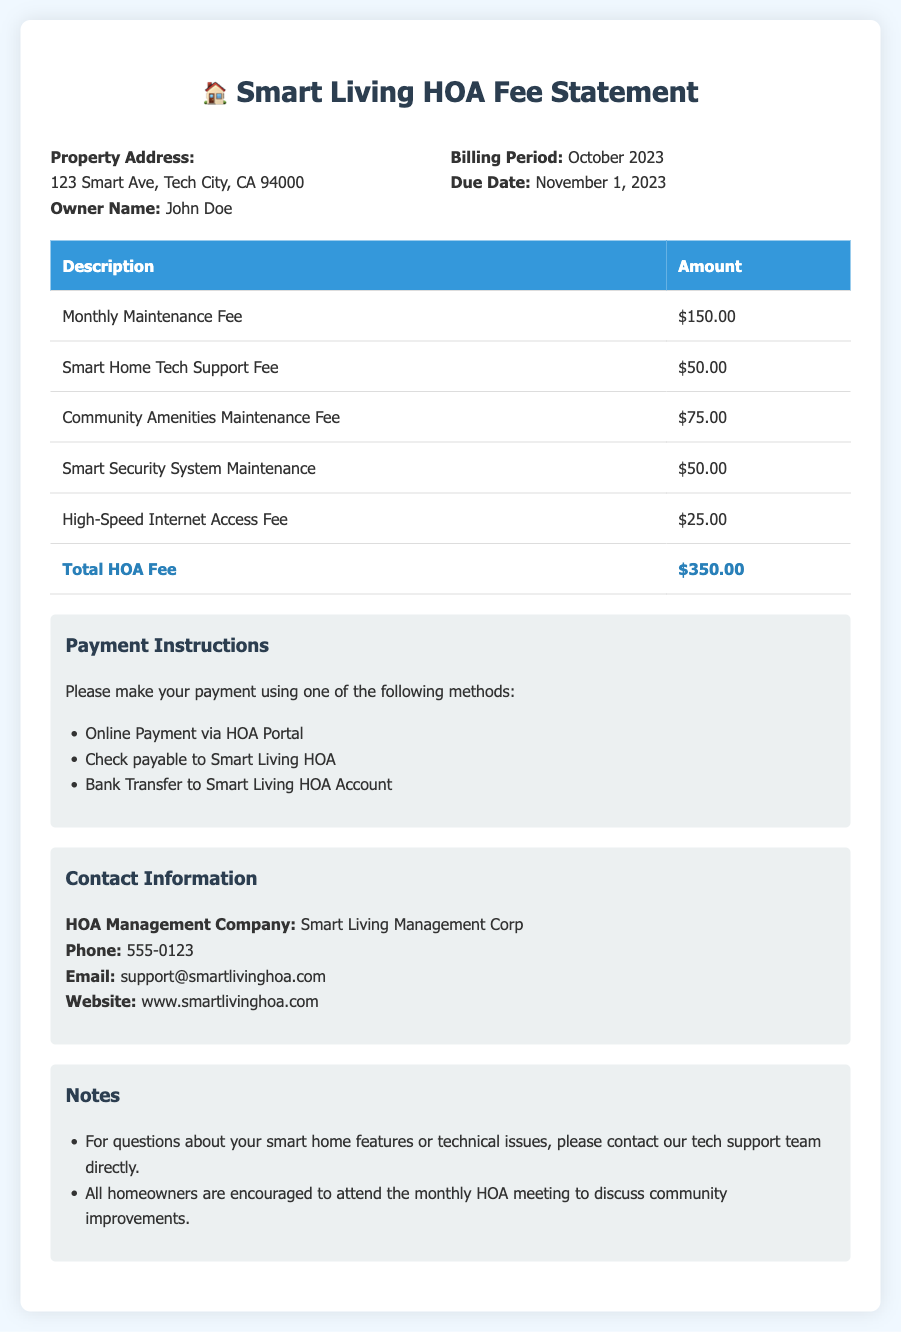What is the property address? The property address is found in the property info section of the document.
Answer: 123 Smart Ave, Tech City, CA 94000 What is the name of the owner? The owner's name is listed in the property info section of the document.
Answer: John Doe What is the billing period? The billing period is stated in the billing info section of the document.
Answer: October 2023 What is the total HOA fee? The total HOA fee is the sum of all fees calculated in the table.
Answer: $350.00 How much is the Smart Home Tech Support Fee? The Smart Home Tech Support Fee can be found in the table of fees.
Answer: $50.00 What is one method of payment listed? Payment methods are described in the payment info section of the document.
Answer: Online Payment via HOA Portal Who is the HOA management company? The HOA management company is identified in the contact information section.
Answer: Smart Living Management Corp What is the due date for the payment? The due date is specified in the billing info section of the document.
Answer: November 1, 2023 How much is the High-Speed Internet Access Fee? The fee for High-Speed Internet Access is itemized in the fee table.
Answer: $25.00 